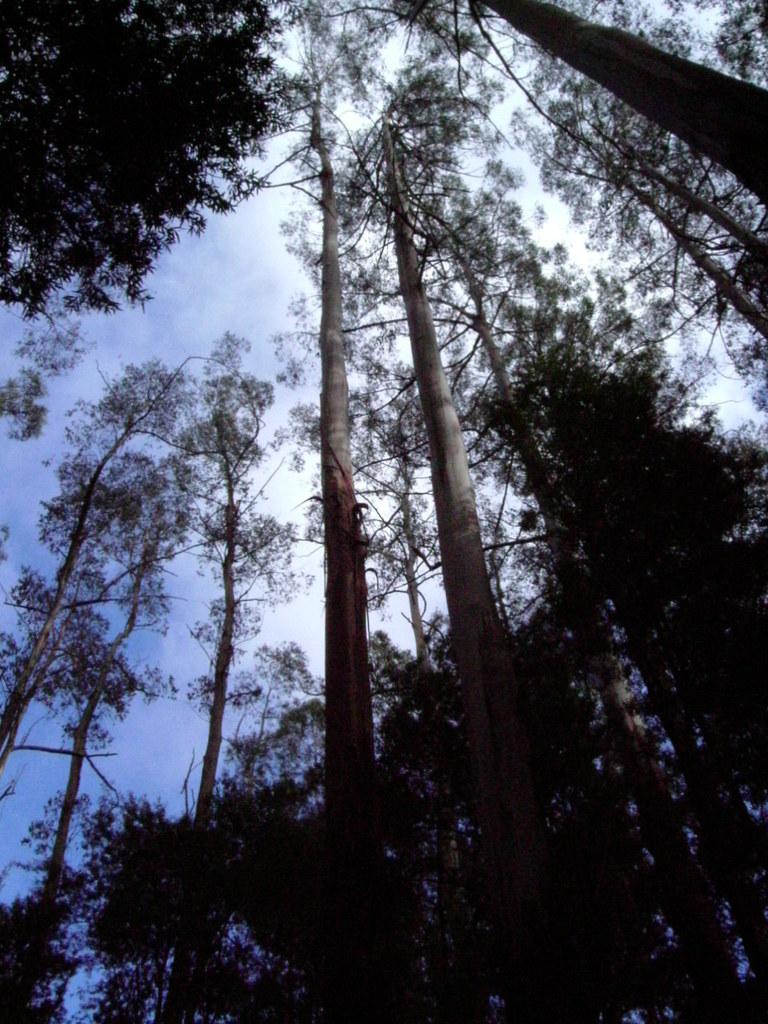Could you give a brief overview of what you see in this image? In this picture I can see few tall trees and I can see a blue cloudy sky. 